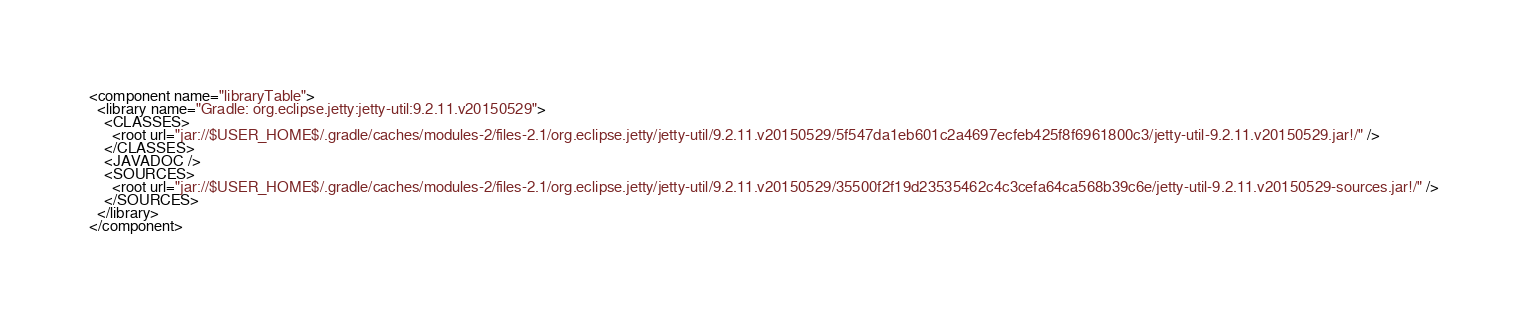<code> <loc_0><loc_0><loc_500><loc_500><_XML_><component name="libraryTable">
  <library name="Gradle: org.eclipse.jetty:jetty-util:9.2.11.v20150529">
    <CLASSES>
      <root url="jar://$USER_HOME$/.gradle/caches/modules-2/files-2.1/org.eclipse.jetty/jetty-util/9.2.11.v20150529/5f547da1eb601c2a4697ecfeb425f8f6961800c3/jetty-util-9.2.11.v20150529.jar!/" />
    </CLASSES>
    <JAVADOC />
    <SOURCES>
      <root url="jar://$USER_HOME$/.gradle/caches/modules-2/files-2.1/org.eclipse.jetty/jetty-util/9.2.11.v20150529/35500f2f19d23535462c4c3cefa64ca568b39c6e/jetty-util-9.2.11.v20150529-sources.jar!/" />
    </SOURCES>
  </library>
</component></code> 